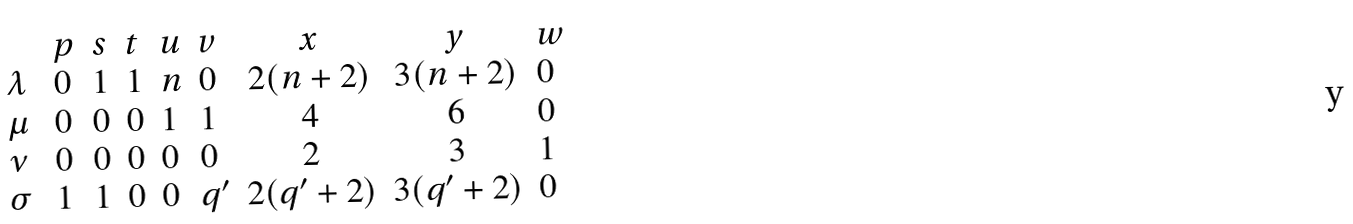Convert formula to latex. <formula><loc_0><loc_0><loc_500><loc_500>\begin{array} { l l l l l l c c l } & p & s & t & u & v & x & y & w \\ \lambda \ & 0 & 1 & 1 & n & 0 & 2 ( n + 2 ) & 3 ( n + 2 ) & 0 \\ \mu \ & 0 & 0 & 0 & 1 & 1 & 4 & 6 & 0 \\ \nu \ & 0 & 0 & 0 & 0 & 0 & 2 & 3 & 1 \\ \sigma \ & 1 & 1 & 0 & 0 & q ^ { \prime } & 2 ( q ^ { \prime } + 2 ) & 3 ( q ^ { \prime } + 2 ) & 0 \\ \end{array}</formula> 